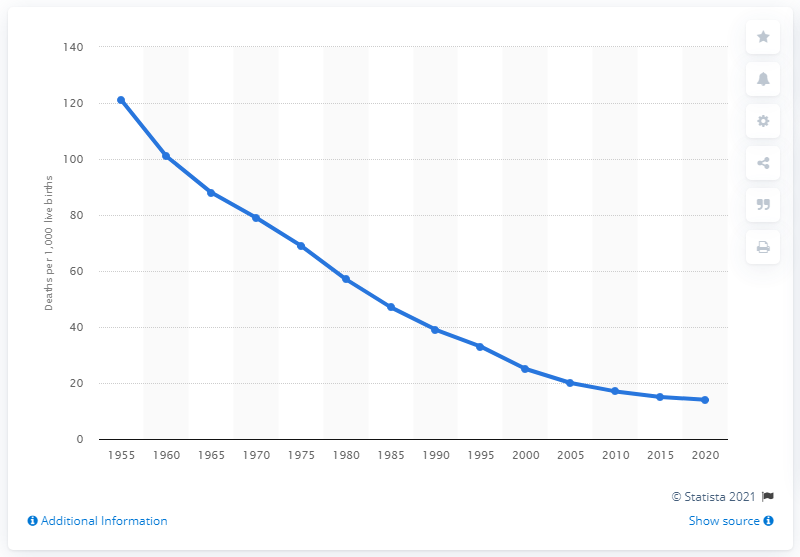Specify some key components in this picture. In 1955, the infant mortality rate in Mexico was 121 per 1,000 live births. 